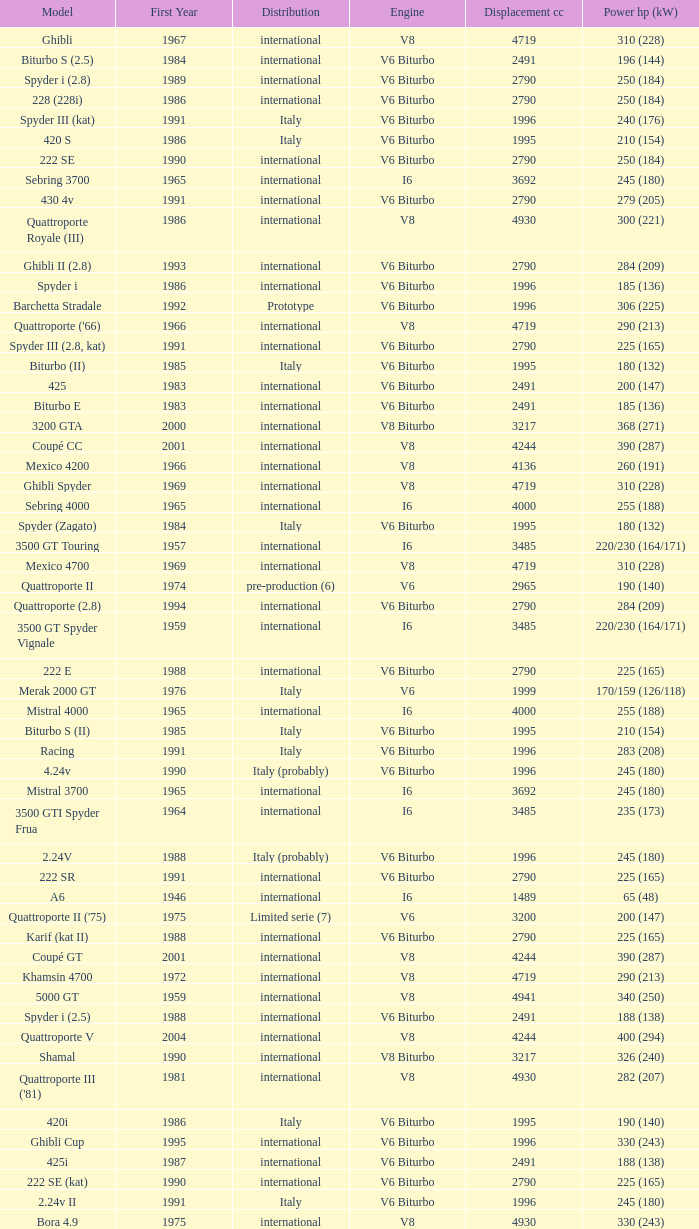Parse the table in full. {'header': ['Model', 'First Year', 'Distribution', 'Engine', 'Displacement cc', 'Power hp (kW)'], 'rows': [['Ghibli', '1967', 'international', 'V8', '4719', '310 (228)'], ['Biturbo S (2.5)', '1984', 'international', 'V6 Biturbo', '2491', '196 (144)'], ['Spyder i (2.8)', '1989', 'international', 'V6 Biturbo', '2790', '250 (184)'], ['228 (228i)', '1986', 'international', 'V6 Biturbo', '2790', '250 (184)'], ['Spyder III (kat)', '1991', 'Italy', 'V6 Biturbo', '1996', '240 (176)'], ['420 S', '1986', 'Italy', 'V6 Biturbo', '1995', '210 (154)'], ['222 SE', '1990', 'international', 'V6 Biturbo', '2790', '250 (184)'], ['Sebring 3700', '1965', 'international', 'I6', '3692', '245 (180)'], ['430 4v', '1991', 'international', 'V6 Biturbo', '2790', '279 (205)'], ['Quattroporte Royale (III)', '1986', 'international', 'V8', '4930', '300 (221)'], ['Ghibli II (2.8)', '1993', 'international', 'V6 Biturbo', '2790', '284 (209)'], ['Spyder i', '1986', 'international', 'V6 Biturbo', '1996', '185 (136)'], ['Barchetta Stradale', '1992', 'Prototype', 'V6 Biturbo', '1996', '306 (225)'], ["Quattroporte ('66)", '1966', 'international', 'V8', '4719', '290 (213)'], ['Spyder III (2.8, kat)', '1991', 'international', 'V6 Biturbo', '2790', '225 (165)'], ['Biturbo (II)', '1985', 'Italy', 'V6 Biturbo', '1995', '180 (132)'], ['425', '1983', 'international', 'V6 Biturbo', '2491', '200 (147)'], ['Biturbo E', '1983', 'international', 'V6 Biturbo', '2491', '185 (136)'], ['3200 GTA', '2000', 'international', 'V8 Biturbo', '3217', '368 (271)'], ['Coupé CC', '2001', 'international', 'V8', '4244', '390 (287)'], ['Mexico 4200', '1966', 'international', 'V8', '4136', '260 (191)'], ['Ghibli Spyder', '1969', 'international', 'V8', '4719', '310 (228)'], ['Sebring 4000', '1965', 'international', 'I6', '4000', '255 (188)'], ['Spyder (Zagato)', '1984', 'Italy', 'V6 Biturbo', '1995', '180 (132)'], ['3500 GT Touring', '1957', 'international', 'I6', '3485', '220/230 (164/171)'], ['Mexico 4700', '1969', 'international', 'V8', '4719', '310 (228)'], ['Quattroporte II', '1974', 'pre-production (6)', 'V6', '2965', '190 (140)'], ['Quattroporte (2.8)', '1994', 'international', 'V6 Biturbo', '2790', '284 (209)'], ['3500 GT Spyder Vignale', '1959', 'international', 'I6', '3485', '220/230 (164/171)'], ['222 E', '1988', 'international', 'V6 Biturbo', '2790', '225 (165)'], ['Merak 2000 GT', '1976', 'Italy', 'V6', '1999', '170/159 (126/118)'], ['Mistral 4000', '1965', 'international', 'I6', '4000', '255 (188)'], ['Biturbo S (II)', '1985', 'Italy', 'V6 Biturbo', '1995', '210 (154)'], ['Racing', '1991', 'Italy', 'V6 Biturbo', '1996', '283 (208)'], ['4.24v', '1990', 'Italy (probably)', 'V6 Biturbo', '1996', '245 (180)'], ['Mistral 3700', '1965', 'international', 'I6', '3692', '245 (180)'], ['3500 GTI Spyder Frua', '1964', 'international', 'I6', '3485', '235 (173)'], ['2.24V', '1988', 'Italy (probably)', 'V6 Biturbo', '1996', '245 (180)'], ['222 SR', '1991', 'international', 'V6 Biturbo', '2790', '225 (165)'], ['A6', '1946', 'international', 'I6', '1489', '65 (48)'], ["Quattroporte II ('75)", '1975', 'Limited serie (7)', 'V6', '3200', '200 (147)'], ['Karif (kat II)', '1988', 'international', 'V6 Biturbo', '2790', '225 (165)'], ['Coupé GT', '2001', 'international', 'V8', '4244', '390 (287)'], ['Khamsin 4700', '1972', 'international', 'V8', '4719', '290 (213)'], ['5000 GT', '1959', 'international', 'V8', '4941', '340 (250)'], ['Spyder i (2.5)', '1988', 'international', 'V6 Biturbo', '2491', '188 (138)'], ['Quattroporte V', '2004', 'international', 'V8', '4244', '400 (294)'], ['Shamal', '1990', 'international', 'V8 Biturbo', '3217', '326 (240)'], ["Quattroporte III ('81)", '1981', 'international', 'V8', '4930', '282 (207)'], ['420i', '1986', 'Italy', 'V6 Biturbo', '1995', '190 (140)'], ['Ghibli Cup', '1995', 'international', 'V6 Biturbo', '1996', '330 (243)'], ['425i', '1987', 'international', 'V6 Biturbo', '2491', '188 (138)'], ['222 SE (kat)', '1990', 'international', 'V6 Biturbo', '2790', '225 (165)'], ['2.24v II', '1991', 'Italy', 'V6 Biturbo', '1996', '245 (180)'], ['Bora 4.9', '1975', 'international', 'V8', '4930', '330 (243)'], ['Ghibli II (2.0)', '1992', 'Italy', 'V6 Biturbo', '1996', '306 (225)'], ['Biturbo Si', '1987', 'Italy', 'V6 Biturbo', '1995', '220 (162)'], ["Spyder i ('90)", '1989', 'Italy', 'V6 Biturbo', '1996', '220 (162)'], ['Spyder i (2.8, kat)', '1989', 'international', 'V6 Biturbo', '2790', '225 (165)'], ['Kyalami 4900', '1978', 'international', 'V8', '4930', '280 (206)'], ['Ghibli SS', '1970', 'international', 'V8', '4930', '335 (246)'], ['Biturbo', '1981', 'Italy', 'V6 Biturbo', '1995', '180 (132)'], ['Quattroporte V6 Evoluzione', '1998', 'international', 'V6 Biturbo', '2790', '284 (209)'], ['Kyalami 4200', '1976', 'international', 'V8', '4136', '265/253 (197/188)'], ['2.24v II (kat)', '1991', 'international (probably)', 'V6 Biturbo', '1996', '240 (176)'], ['Biturbo S', '1983', 'Italy', 'V6 Biturbo', '1995', '205 (151)'], ['Indy Europa 4700', '1971', 'international', 'V8', '4719', '290 (213)'], ['Biturbo i', '1986', 'Italy', 'V6 Biturbo', '1995', '185 (136)'], ['Karif', '1988', 'international', 'V6 Biturbo', '2790', '285 (210)'], ['Spyder III', '1991', 'Italy', 'V6 Biturbo', '1996', '245 (180)'], ['GranTurismo', '2008', 'international', 'V8', '4244', '405'], ['4.18v', '1990', 'Italy', 'V6 Biturbo', '1995', '220 (162)'], ['Spyder GT', '2001', 'international', 'V8', '4244', '390 (287)'], ["Merak SS ('79)", '1979', 'international', 'V6', '2965', '208 (153)'], ['Bora 4.9 (US)', '1974', 'USA only', 'V8', '4930', '300 (221)'], ['430', '1987', 'international', 'V6 Biturbo', '2790', '225 (165)'], ["Spyder i ('87)", '1987', 'international', 'V6 Biturbo', '1996', '195 (143)'], ["Khamsin ('79)", '1979', 'international', 'V8', '4930', '280 (206)'], ['Mistral 3500', '1963', 'international', 'I6', '3485', '235 (173)'], ['Ghibli Primatist', '1996', 'international', 'V6 Biturbo', '1996', '306 (225)'], ["A6G54 ('56)", '1956', 'international', 'I6', '1986', '160 (118)'], ['Khamsin 4900', '1972', 'international', 'V8', '4930', '320 (235)'], ['Biturbo Si (2.5)', '1987', 'international', 'V6 Biturbo', '2491', '188 (138)'], ['Indy 4900', '1973', 'international', 'V8', '4930', '320 (235)'], ['Karif (kat)', '1988', 'international', 'V6 Biturbo', '2790', '248 (182)'], ['Bora 4.7', '1973', 'international', 'V8', '4719', '310 (228)'], ['A6G54', '1954', 'international', 'I6', '1986', '150 (110)'], ['Merak', '1973', 'international', 'V6', '2965', '190 (140)'], ['4.24v II (kat)', '1991', 'Italy (probably)', 'V6 Biturbo', '1996', '240 (176)'], ['228 (228i) Kat', '1986', 'international', 'V6 Biturbo', '2790', '225 (165)'], ['A6G', '1951', 'international', 'I6', '1954', '100 (74)'], ['Mistral 4000 Spyder', '1965', 'international', 'I6', '4000', '255 (188)'], ['Ghibli SS Spyder', '1970', 'international', 'V8', '4930', '335 (246)'], ['3200 GT', '1998', 'international', 'V8 Biturbo', '3217', '370 (272)'], ['222', '1988', 'Italy', 'V6 Biturbo', '1996', '220 (162)'], ['Barchetta Stradale 2.8', '1992', 'Single, Conversion', 'V6 Biturbo', '2790', '284 (209)'], ['Gran Sport', '2002', 'international', 'V8', '4244', '400 (294)'], ['Indy Europa 4200', '1970', 'international', 'V8', '4136', '260 (191)'], ['Quattroporte (2.0)', '1994', 'Italy', 'V6 Biturbo', '1996', '287 (211)'], ['GranCabrio', '2010', 'international', 'V8', '4691', '433'], ['Spyder (2.5)', '1984', 'international', 'V6 Biturbo', '2491', '192 (141)'], ['Biturbo E (II 2.5)', '1985', 'international', 'V6 Biturbo', '2491', '185 (136)'], ['3500 GTI', '1962', 'international', 'I6', '3485', '235 (173)'], ['Spyder CC', '2001', 'international', 'V8', '4244', '390 (287)'], ['Mistral 3700 Spyder', '1965', 'international', 'I6', '3692', '245 (180)'], ['3500 GTI Spyder', '1962', 'international', 'I6', '3485', '235 (173)'], ['Quattroporte', '1963', 'international', 'V8', '4136', '260 (191)'], ['222 4v', '1988', 'international', 'V6 Biturbo', '2790', '279 (205)'], ['4porte (Quattroporte III)', '1976', 'international', 'V8', '4136', '255 (188)'], ["5000 GT ('61)", '1961', 'international', 'V8', '4941', '330 (243)'], ['MC12 (aka MCC)', '2004', 'Limited', 'V12', '5998', '630 (463)'], ['Quattroporte Ottocilindri', '1995', 'international', 'V8 Biturbo', '3217', '335 (246)'], ['420', '1985', 'Italy', 'V6 Biturbo', '1995', '180 (132)'], ['Quattroporte V8 Evoluzione', '1998', 'international', 'V8 Biturbo', '3217', '335 (246)'], ['Merak SS', '1975', 'international', 'V6', '2965', '220 (162)'], ['422', '1988', 'Italy', 'V6 Biturbo', '1996', '220 (162)']]} What is the total number of First Year, when Displacement CC is greater than 4719, when Engine is V8, when Power HP (kW) is "335 (246)", and when Model is "Ghibli SS"? 1.0. 